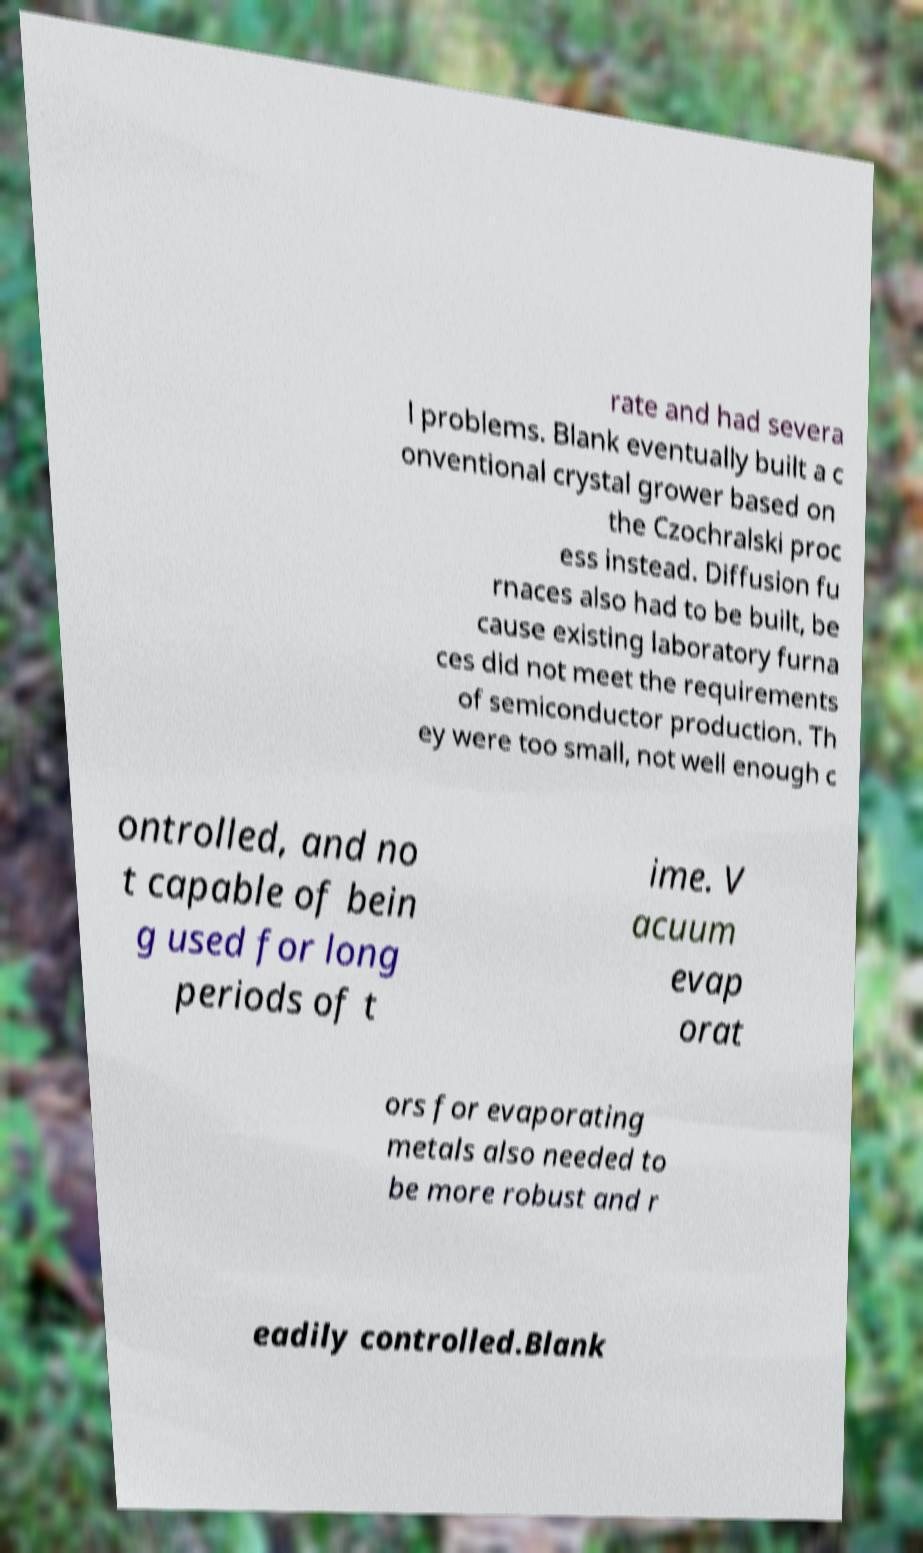Could you assist in decoding the text presented in this image and type it out clearly? rate and had severa l problems. Blank eventually built a c onventional crystal grower based on the Czochralski proc ess instead. Diffusion fu rnaces also had to be built, be cause existing laboratory furna ces did not meet the requirements of semiconductor production. Th ey were too small, not well enough c ontrolled, and no t capable of bein g used for long periods of t ime. V acuum evap orat ors for evaporating metals also needed to be more robust and r eadily controlled.Blank 